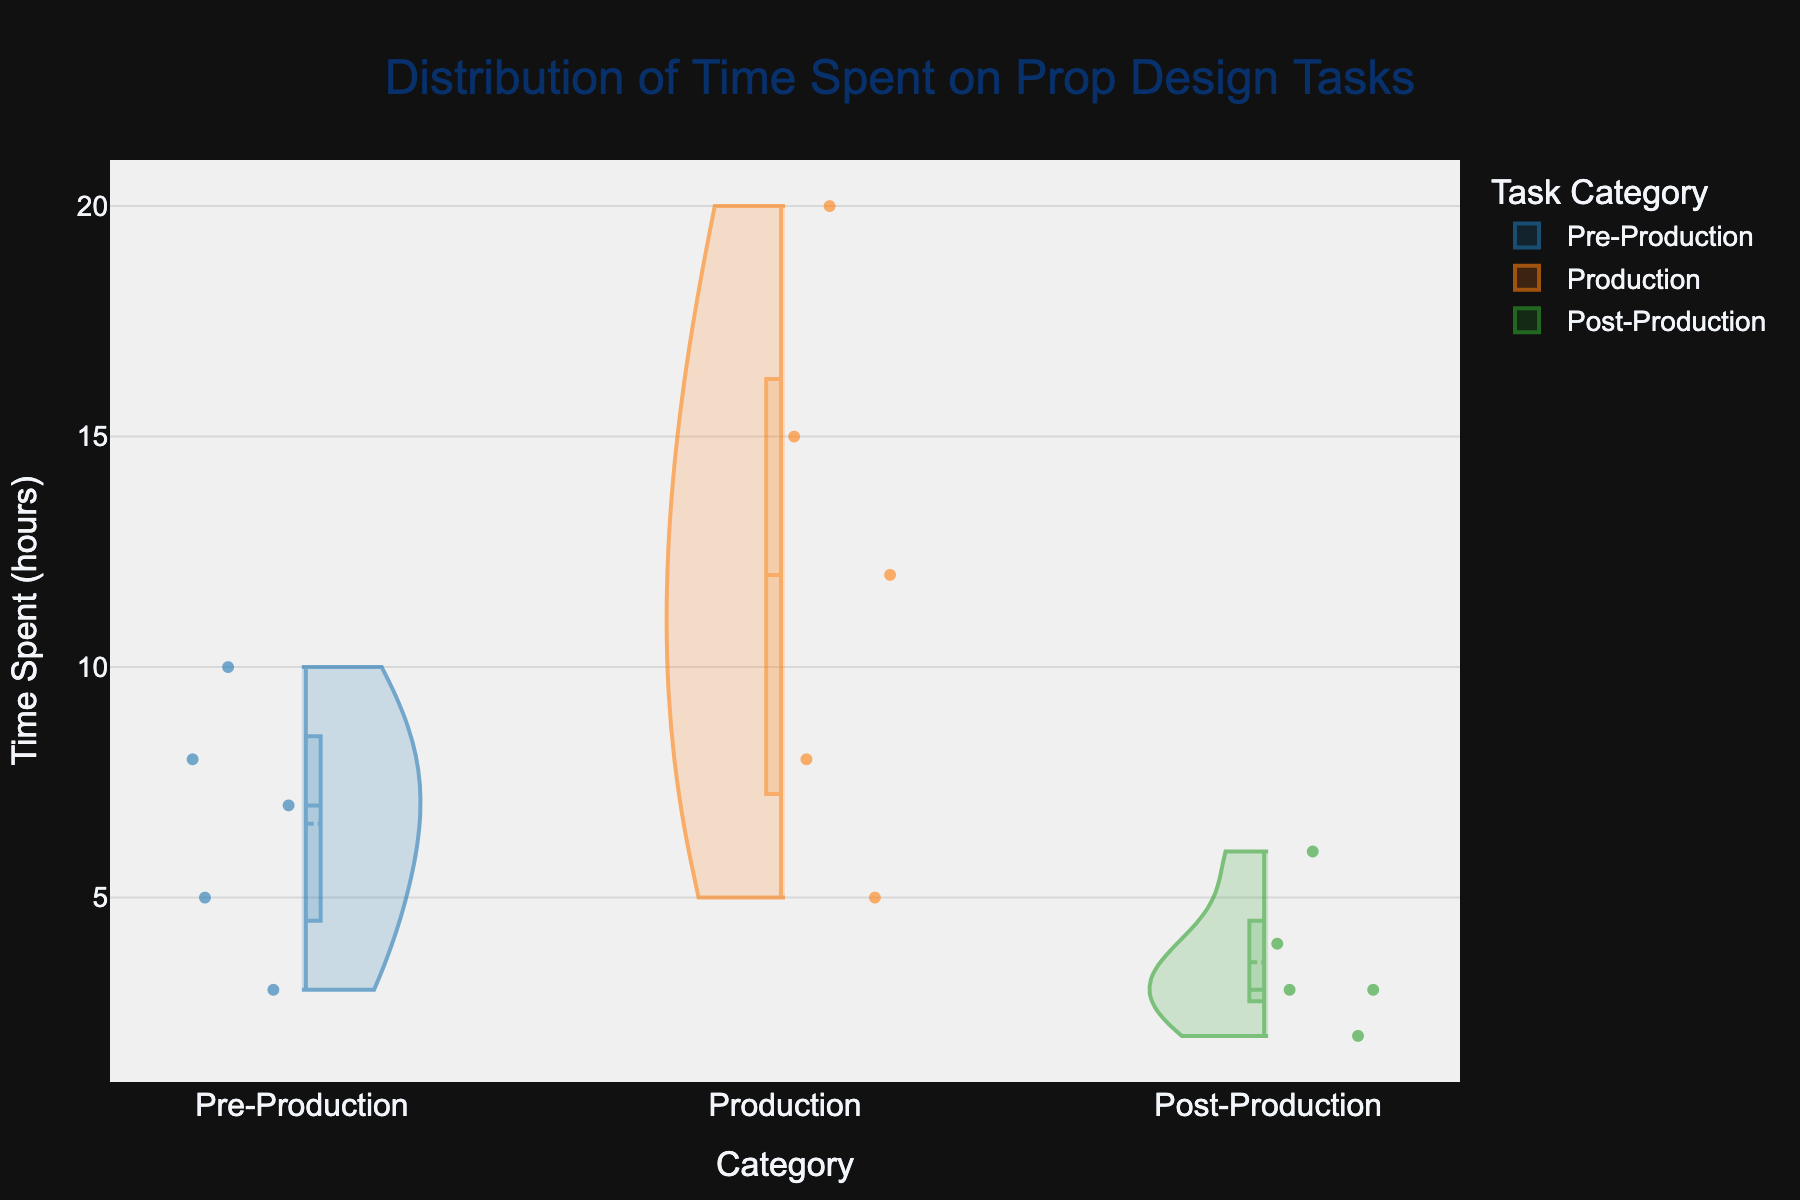What is the title of the figure? The title is located at the top of the figure. Reading it directly from the figure, we see "Distribution of Time Spent on Prop Design Tasks."
Answer: Distribution of Time Spent on Prop Design Tasks How many subcategories are there in the Pre-Production category? Each data point corresponds to a subcategory within Pre-Production. There are 5 violins representing the 5 subcategories: Conceptualizing, Research, Sketching, Material Selection, and Budget Planning.
Answer: 5 Which category has the highest maximum time spent? By observing the highest points on the y-axis across all categories, the Production category has the highest maximum time spent of 20 hours for Building Props.
Answer: Production What is the average time spent on tasks in the Post-Production category? The time spent on each task in the Post-Production category is: 4, 3, 2, 6, and 3 hours. Summing these values gives 18 hours, and there are 5 tasks, so the average is 18/5 = 3.6 hours.
Answer: 3.6 hours What is the most time-consuming task in the Production category? By looking at the y-axis values for the Production category, the highest time spent is 20 hours on the task "Building Props."
Answer: Building Props Compare the time spent on Research in Pre-Production and Cleaning & Maintenance in Post-Production. Which is higher? The time spent on Research in Pre-Production is 10 hours. The time spent on Cleaning & Maintenance in Post-Production is 4 hours. 10 hours is greater than 4 hours, so Research in Pre-Production has the higher time spent.
Answer: Research in Pre-Production What is the range of time spent on tasks in Pre-Production? The range is calculated by subtracting the minimum time spent from the maximum time spent within Pre-Production. The times are: 8, 10, 5, 7, and 3 hours. The range is 10 - 3 = 7 hours.
Answer: 7 hours How does the distribution of time spent in Pre-Production compare to Production? By examining the violin plots, Pre-Production shows a wider spread with values from 3 to 10 hours and more data points at the lower end. Production shows higher values overall with a concentration of tasks around 8 to 20 hours.
Answer: Production shows higher values overall What is the median time spent on tasks in the Production category? For the Production category, the times are: 20, 15, 12, 8, and 5 hours. The median is the middle value when these are ordered: 5, 8, 12, 15, 20. The middle value is 12 hours.
Answer: 12 hours 